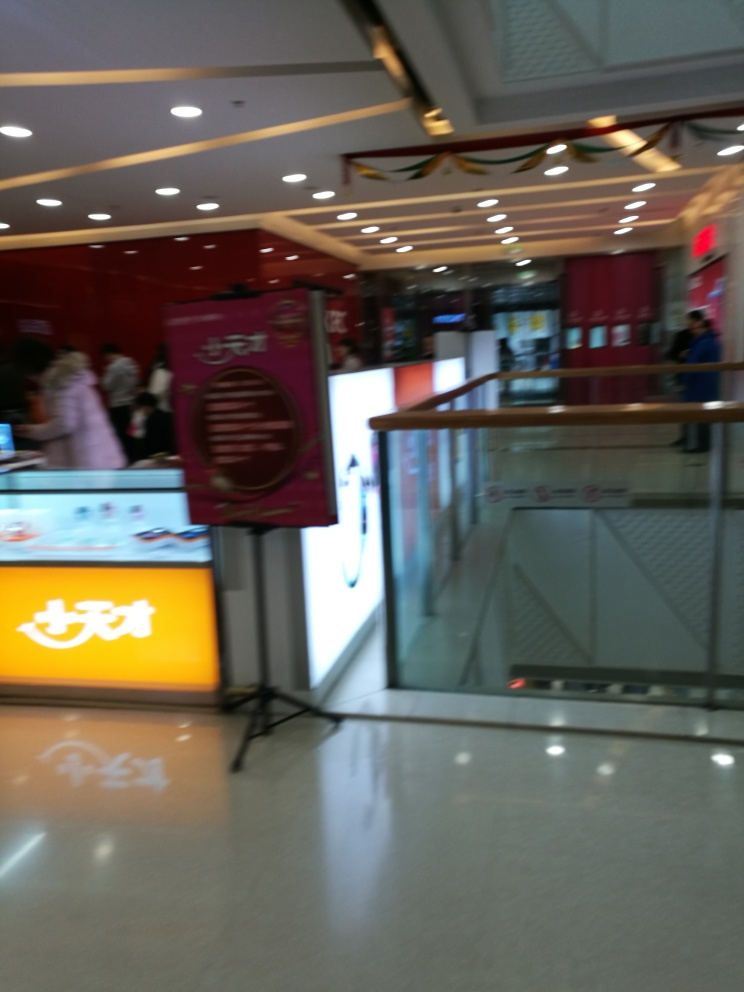Are there any quality issues with this image? Yes, the image is blurry which affects the clarity and detail. It's possible that the image was taken with a low shutter speed while in motion, or the camera was not focused correctly. Additionally, the composition is slightly skewed, suggesting that the image might have been taken hastily without proper alignment. 